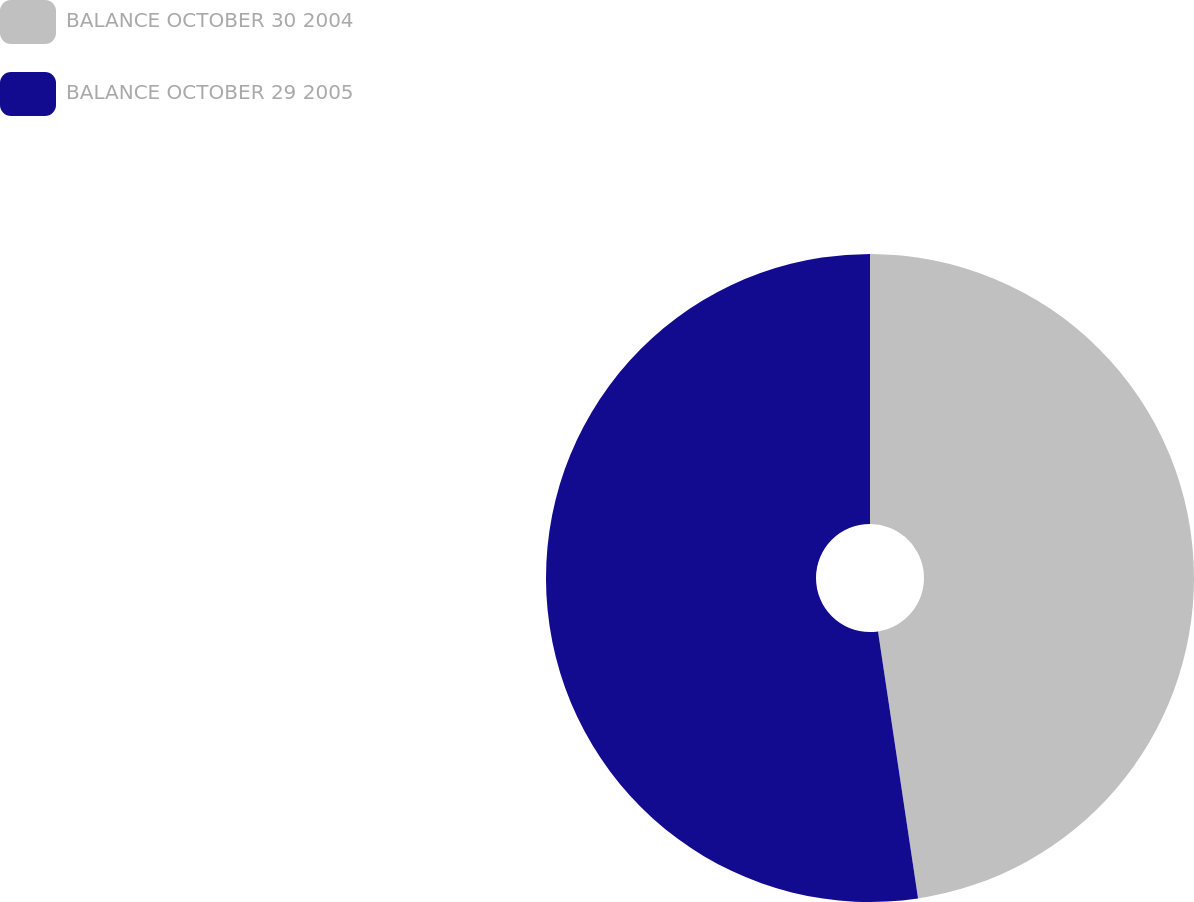Convert chart to OTSL. <chart><loc_0><loc_0><loc_500><loc_500><pie_chart><fcel>BALANCE OCTOBER 30 2004<fcel>BALANCE OCTOBER 29 2005<nl><fcel>47.63%<fcel>52.37%<nl></chart> 